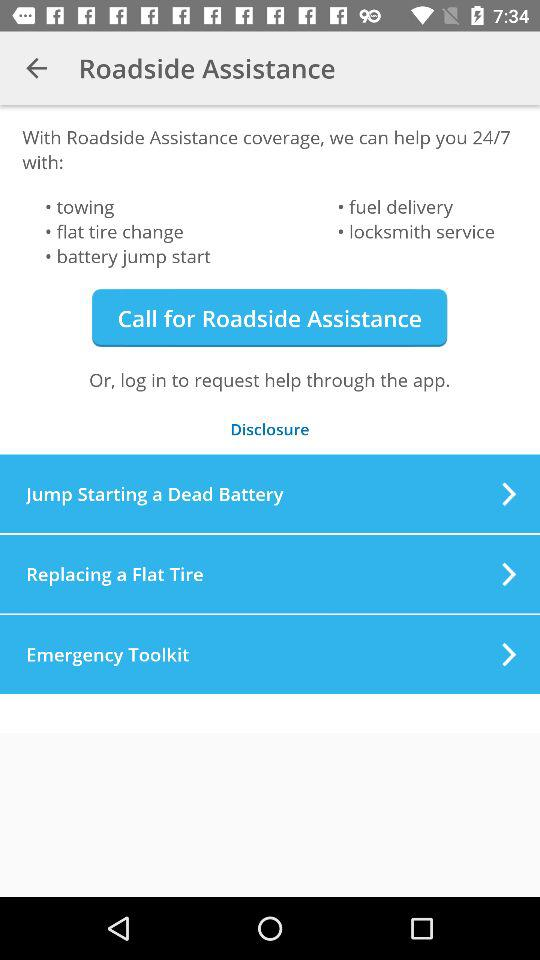What is the name of the application? The name of the application is "Roadside Assistance". 